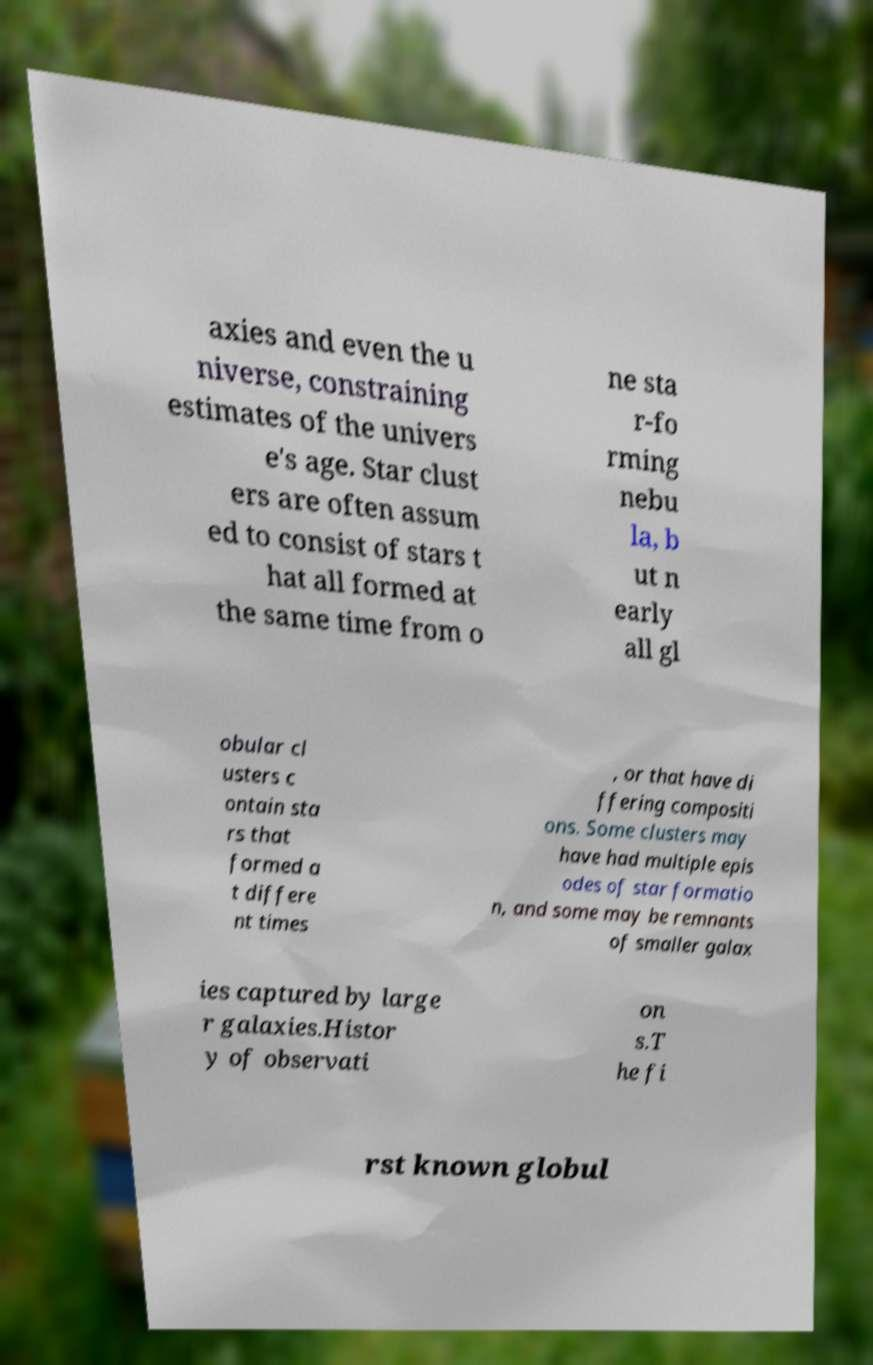Please identify and transcribe the text found in this image. axies and even the u niverse, constraining estimates of the univers e's age. Star clust ers are often assum ed to consist of stars t hat all formed at the same time from o ne sta r-fo rming nebu la, b ut n early all gl obular cl usters c ontain sta rs that formed a t differe nt times , or that have di ffering compositi ons. Some clusters may have had multiple epis odes of star formatio n, and some may be remnants of smaller galax ies captured by large r galaxies.Histor y of observati on s.T he fi rst known globul 